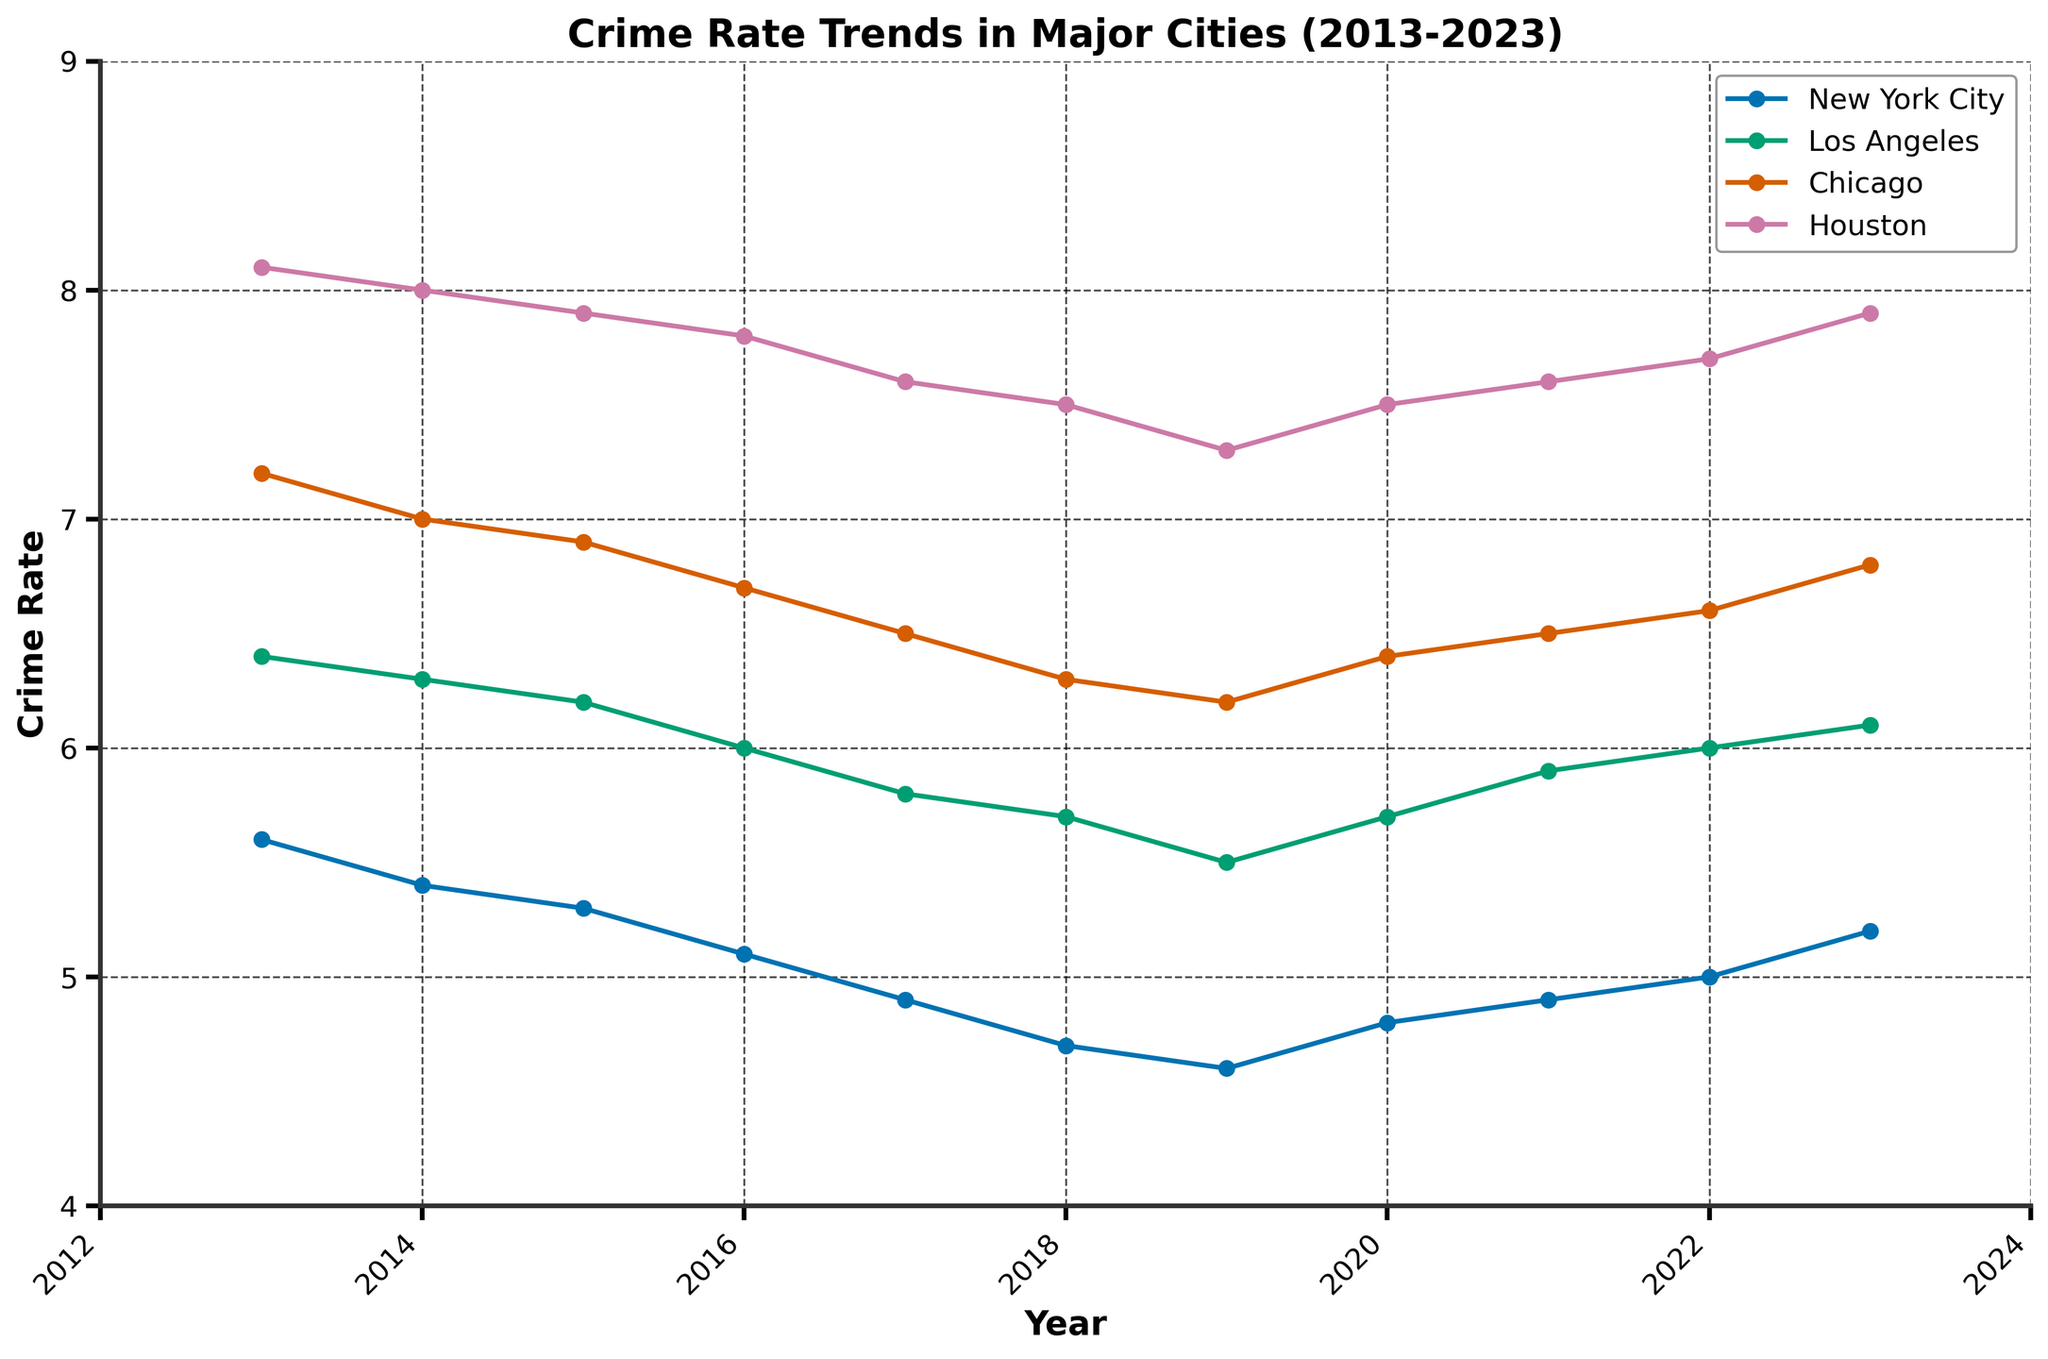What's the title of the figure? The title is located at the top of the figure and reads 'Crime Rate Trends in Major Cities (2013-2023)'.
Answer: Crime Rate Trends in Major Cities (2013-2023) Which city had the highest crime rate in January 2013? Look at the data points for January 2013; Houston has the highest value of 8.1.
Answer: Houston How did the crime rate in New York City change from January 2013 to January 2023? Identify the crime rates for New York City at the beginning and end of the time period: 5.6 in 2013 and 5.2 in 2023. Calculate the difference: 5.2 - 5.6 = -0.4. The crime rate decreased by 0.4.
Answer: Decreased by 0.4 Between 2017 and 2018, which city saw the largest decrease in crime rate? Compare the crime rates for each city in 2017 and 2018. New York City decreased from 4.9 to 4.7, Los Angeles from 5.8 to 5.7, Chicago from 6.5 to 6.3, and Houston from 7.6 to 7.5. The largest decrease is New York City's: 4.9 - 4.7 = 0.2.
Answer: New York City What is the overall trend in the crime rate for Chicago from 2013 to 2023? Observe the line for Chicago from 2013 to 2023: It starts at 7.2 and ends at 6.8, with a general downward trend with minor fluctuations.
Answer: Downward trend Which year did Los Angeles experience the lowest crime rate? Identify the year where the Los Angeles line reaches its minimum value. The lowest point is in 2019 with a crime rate of 5.5.
Answer: 2019 Did any city have a crime rate increase every year? Examine each city's line over the years. None of the cities have a continuously increasing crime rate each year; all lines show at least minor decreases at some points.
Answer: No What is the average crime rate for Houston over the entire period shown? Add up all the crime rate values for Houston: 8.1 + 8.0 + 7.9 + 7.8 + 7.6 + 7.5 + 7.3 + 7.5 + 7.6 + 7.7 + 7.9 = 75.9. Divide by the number of years (11): 75.9 / 11 = 6.9.
Answer: 6.9 Between which two consecutive years did Chicago experience the largest increase in its crime rate? Calculate the difference in crime rates for Chicago between consecutive years. The largest increase is between 2019 (6.2) and 2020 (6.4), an increase of 0.2.
Answer: 2019 and 2020 